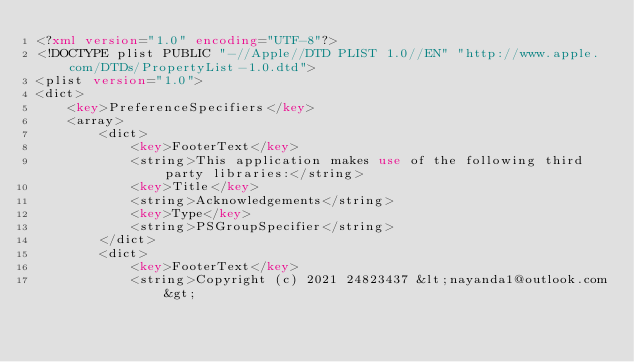<code> <loc_0><loc_0><loc_500><loc_500><_XML_><?xml version="1.0" encoding="UTF-8"?>
<!DOCTYPE plist PUBLIC "-//Apple//DTD PLIST 1.0//EN" "http://www.apple.com/DTDs/PropertyList-1.0.dtd">
<plist version="1.0">
<dict>
	<key>PreferenceSpecifiers</key>
	<array>
		<dict>
			<key>FooterText</key>
			<string>This application makes use of the following third party libraries:</string>
			<key>Title</key>
			<string>Acknowledgements</string>
			<key>Type</key>
			<string>PSGroupSpecifier</string>
		</dict>
		<dict>
			<key>FooterText</key>
			<string>Copyright (c) 2021 24823437 &lt;nayanda1@outlook.com&gt;
</code> 